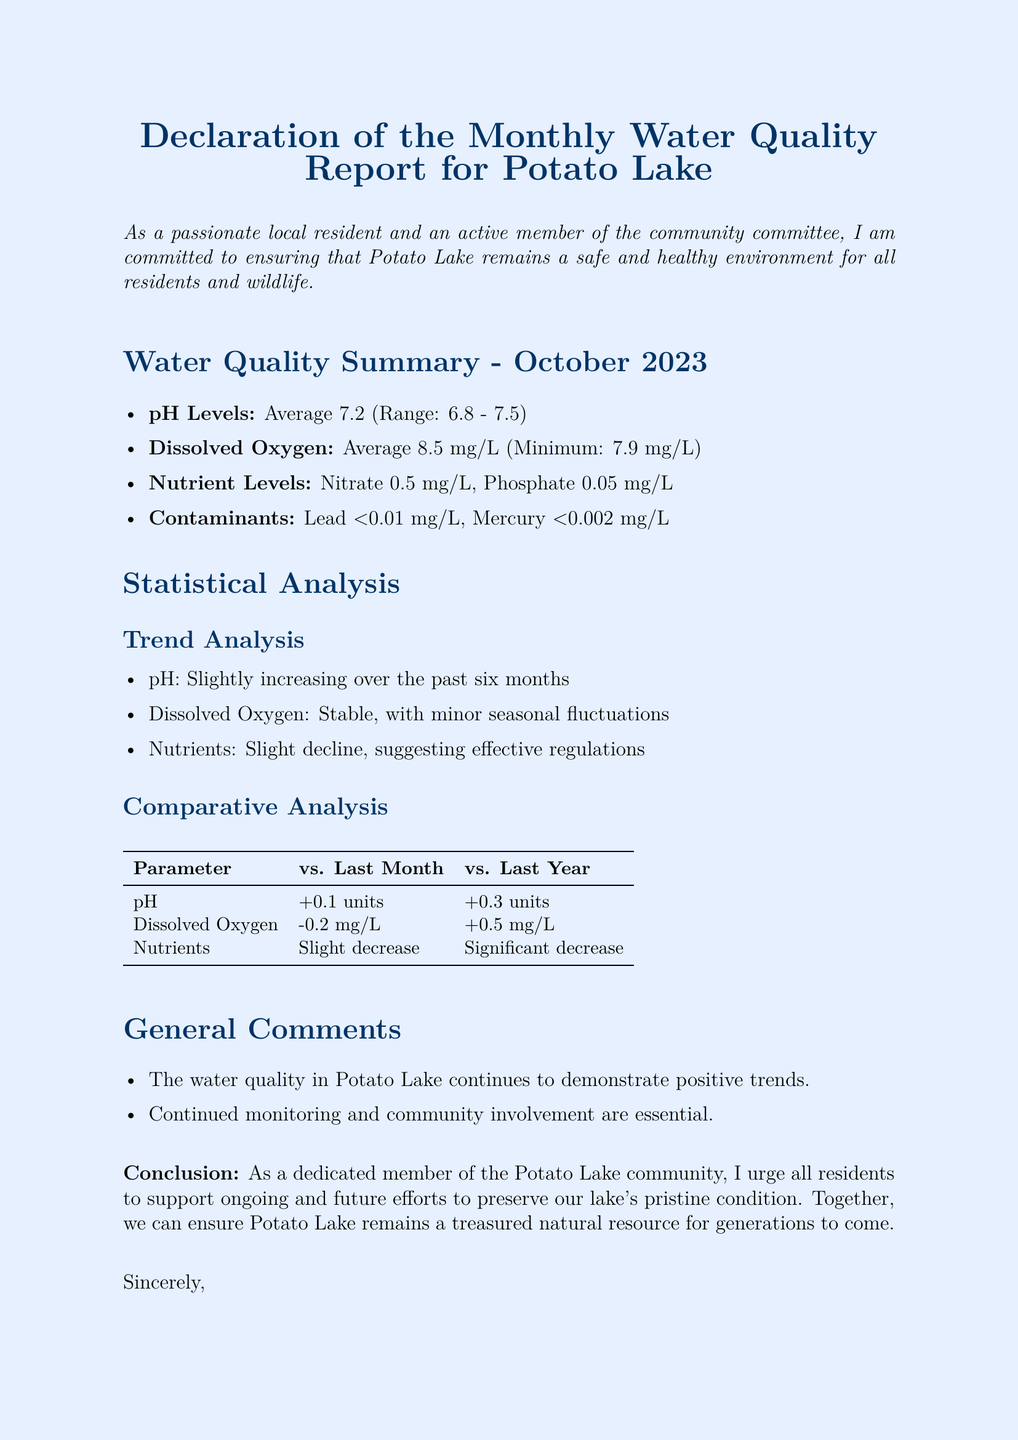What is the average pH level? The average pH level is mentioned in the document under Water Quality Summary as 7.2.
Answer: 7.2 What is the minimum dissolved oxygen level? The document states that the minimum dissolved oxygen level is 7.9 mg/L in the Water Quality Summary.
Answer: 7.9 mg/L What trend does the pH level show over the past six months? The document indicates that the pH level is slightly increasing over the past six months in the Trend Analysis section.
Answer: Slightly increasing What is the lead contaminant level? According to the document, the lead contaminant level is reported as less than 0.01 mg/L in the Water Quality Summary.
Answer: <0.01 mg/L How much did dissolved oxygen decrease compared to last month? The comparative analysis states that dissolved oxygen decreased by 0.2 mg/L compared to last month.
Answer: -0.2 mg/L What is the nutrient level for phosphate? The nutrient level for phosphate is specified as 0.05 mg/L in the Water Quality Summary.
Answer: 0.05 mg/L What is the conclusion urging residents to do? The conclusion emphasizes the importance of supporting ongoing efforts to preserve the lake's condition.
Answer: Support ongoing efforts How do the nutrient levels compare to last year? The document notes a significant decrease in nutrient levels compared to last year in the Comparative Analysis section.
Answer: Significant decrease 